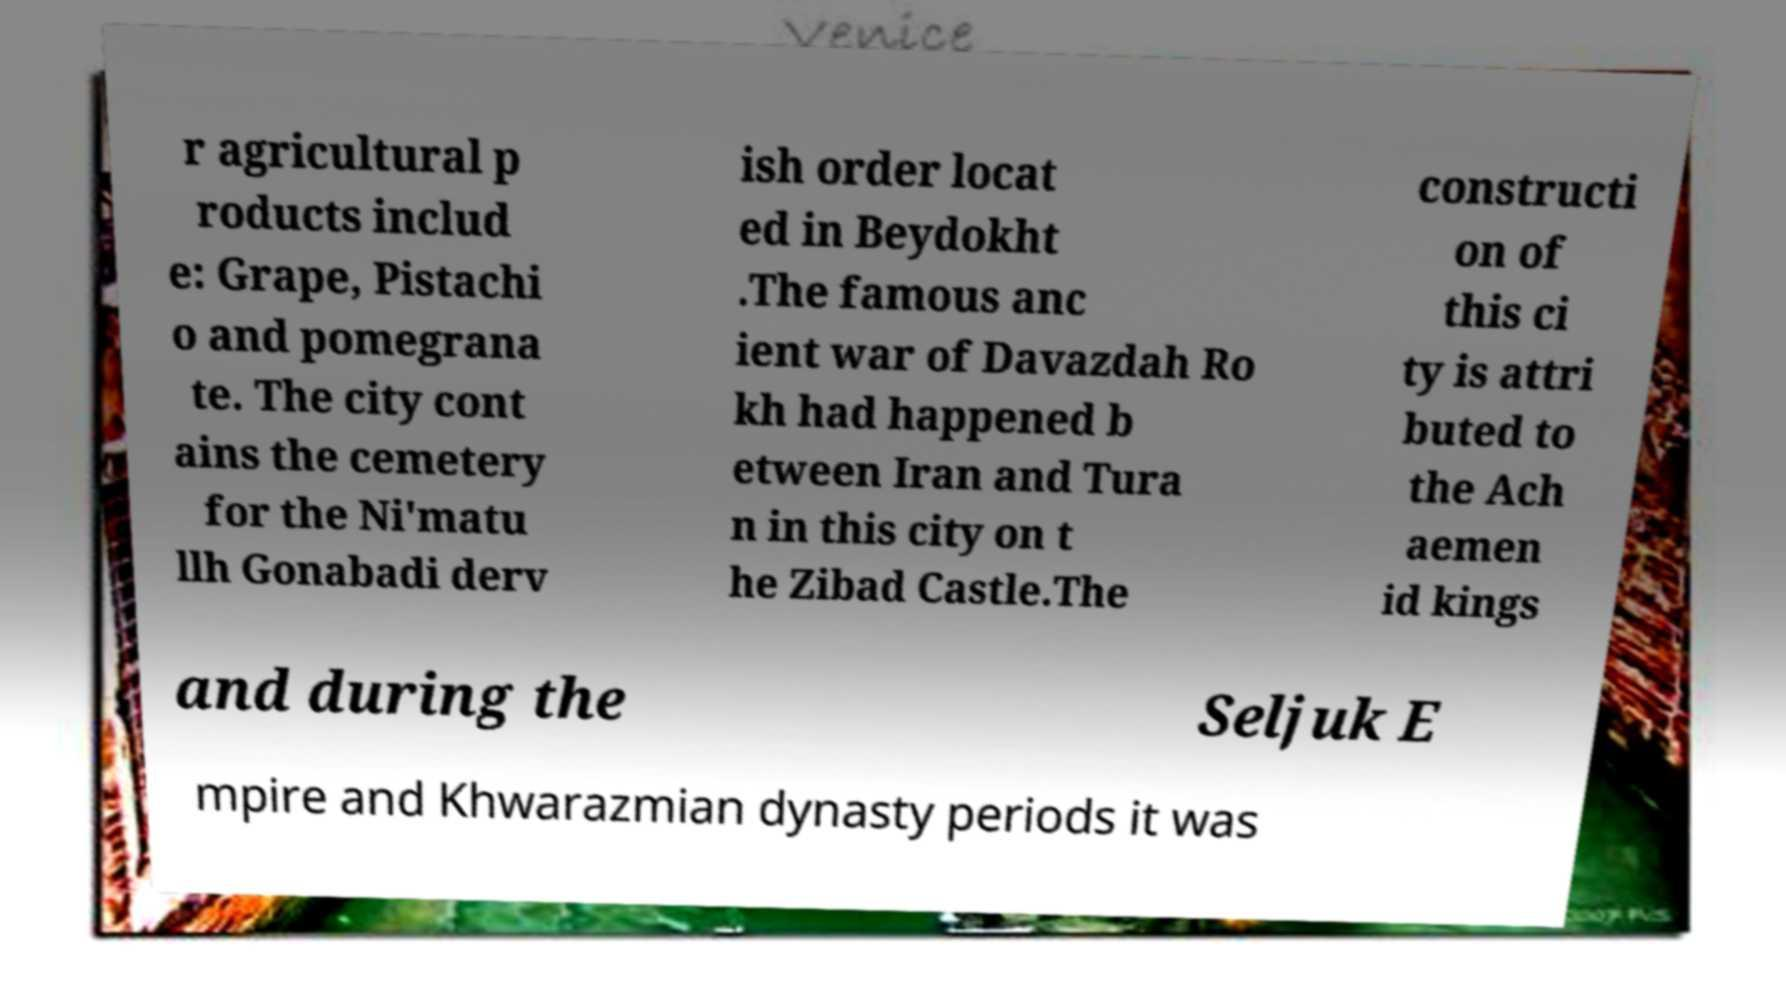Can you read and provide the text displayed in the image?This photo seems to have some interesting text. Can you extract and type it out for me? r agricultural p roducts includ e: Grape, Pistachi o and pomegrana te. The city cont ains the cemetery for the Ni'matu llh Gonabadi derv ish order locat ed in Beydokht .The famous anc ient war of Davazdah Ro kh had happened b etween Iran and Tura n in this city on t he Zibad Castle.The constructi on of this ci ty is attri buted to the Ach aemen id kings and during the Seljuk E mpire and Khwarazmian dynasty periods it was 